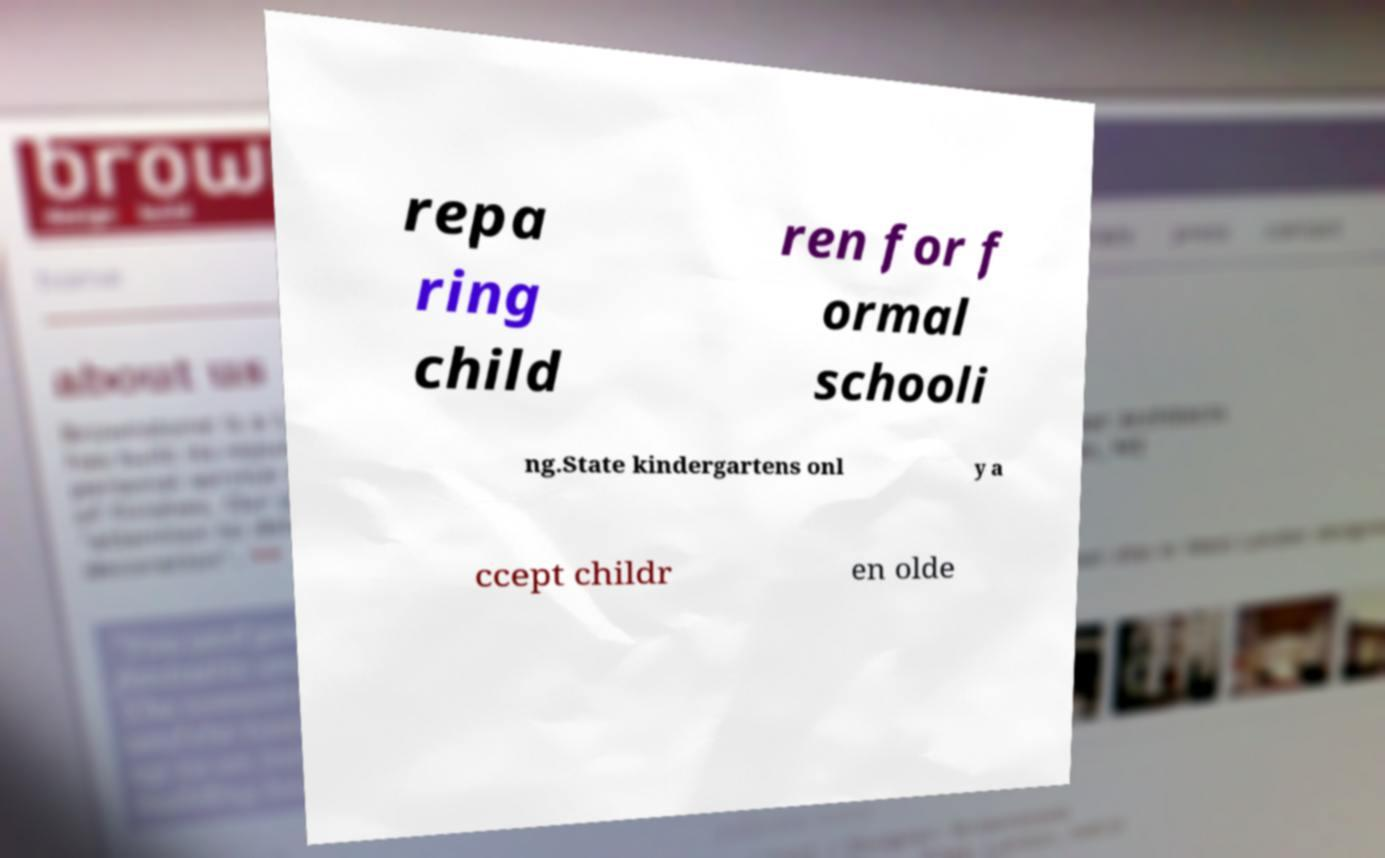I need the written content from this picture converted into text. Can you do that? repa ring child ren for f ormal schooli ng.State kindergartens onl y a ccept childr en olde 